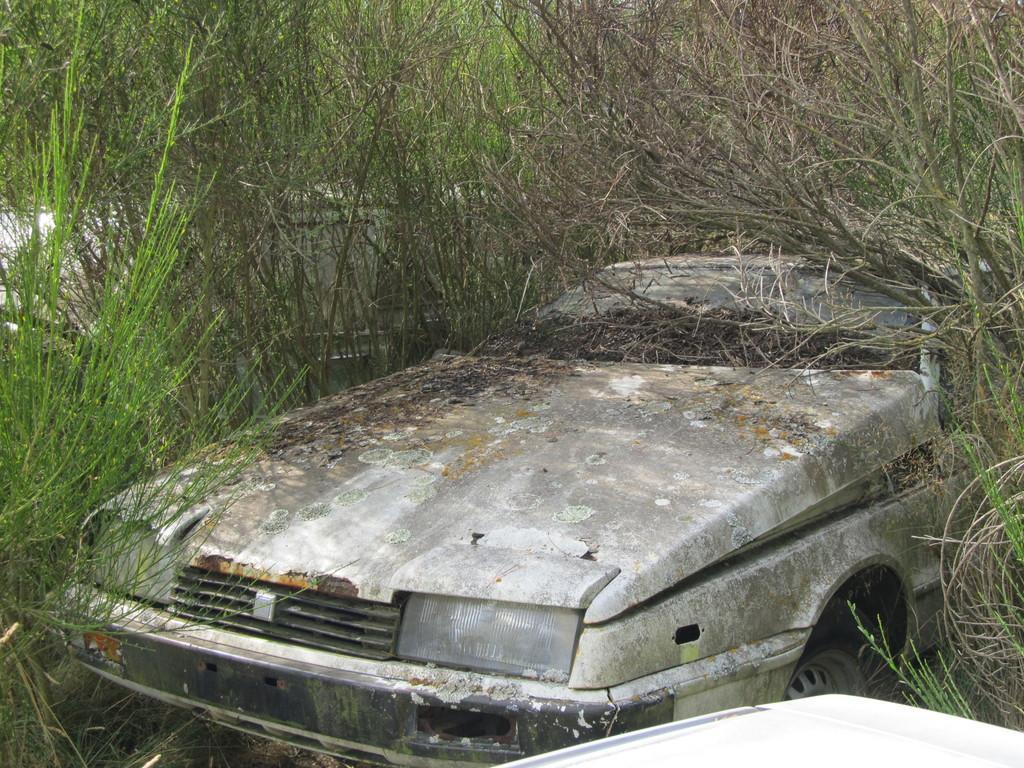Please provide a concise description of this image. In this picture there is an old car in the center of the image and there is grass around the area of the image. 